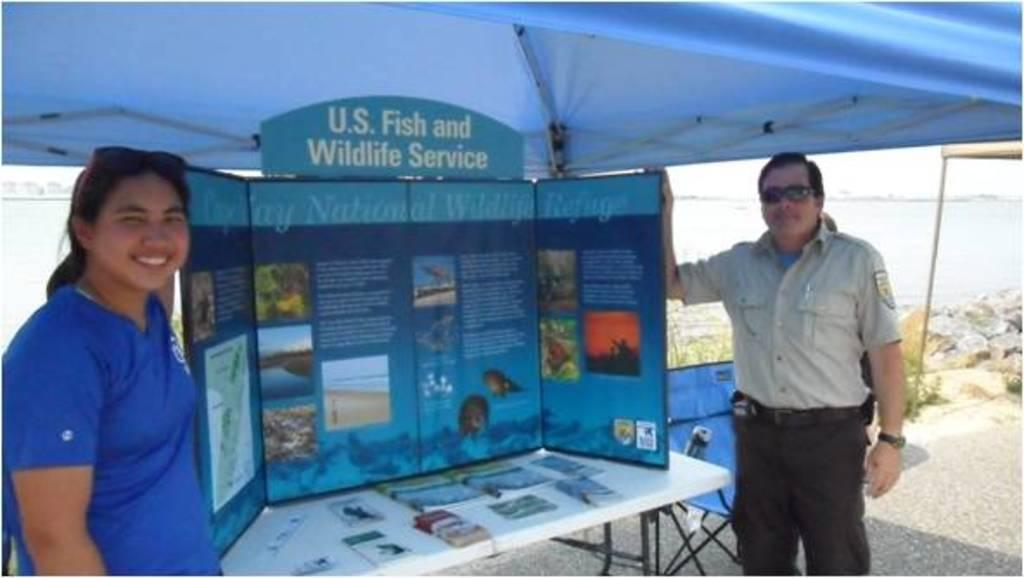How many people are in the image? There are two people in the image, a man and a woman. What are the man and woman holding in the image? The man and woman are holding a board in the image. What is the setting of the image? There is a table and a tent in the image, suggesting an outdoor setting. What can be seen in the background of the image? Water is visible in the background of the image. What flavor of notebook can be seen on the table in the image? There is no notebook present in the image, and therefore no flavor can be determined. Can you see a frog hopping near the tent in the image? There is no frog visible in the image. 